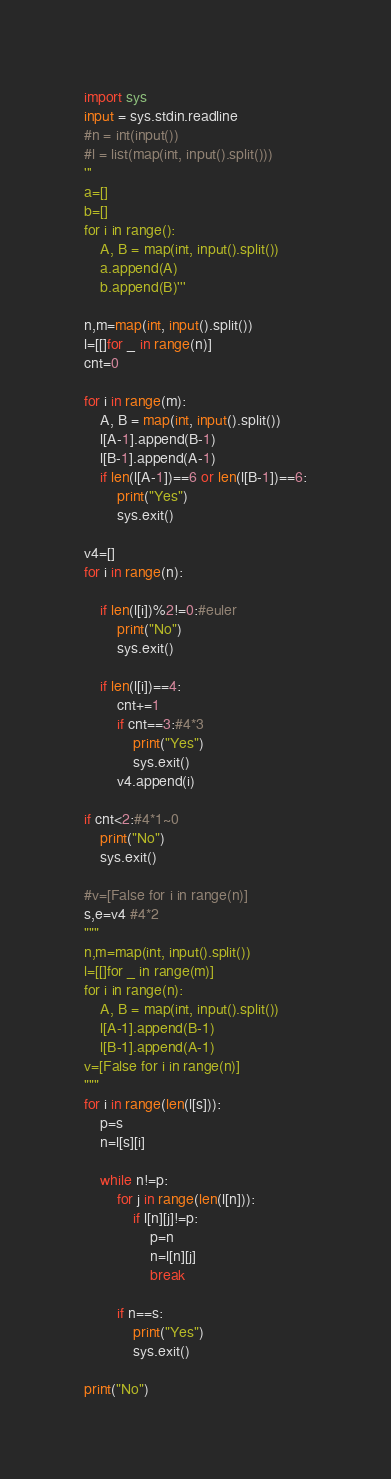Convert code to text. <code><loc_0><loc_0><loc_500><loc_500><_Python_>import sys
input = sys.stdin.readline
#n = int(input())
#l = list(map(int, input().split()))
'''
a=[]
b=[]
for i in range():
    A, B = map(int, input().split())
    a.append(A)
    b.append(B)'''

n,m=map(int, input().split())
l=[[]for _ in range(n)]
cnt=0

for i in range(m):
    A, B = map(int, input().split())
    l[A-1].append(B-1)
    l[B-1].append(A-1)
    if len(l[A-1])==6 or len(l[B-1])==6:
        print("Yes")
        sys.exit()

v4=[]
for i in range(n):

    if len(l[i])%2!=0:#euler
        print("No")
        sys.exit()

    if len(l[i])==4:
        cnt+=1
        if cnt==3:#4*3
            print("Yes")
            sys.exit()
        v4.append(i)

if cnt<2:#4*1~0
    print("No")
    sys.exit()

#v=[False for i in range(n)]
s,e=v4 #4*2
"""
n,m=map(int, input().split())
l=[[]for _ in range(m)]
for i in range(n):
    A, B = map(int, input().split())
    l[A-1].append(B-1)
    l[B-1].append(A-1)
v=[False for i in range(n)]
"""
for i in range(len(l[s])):
    p=s
    n=l[s][i]

    while n!=p:
        for j in range(len(l[n])):
            if l[n][j]!=p:
                p=n
                n=l[n][j]
                break
        
        if n==s:
            print("Yes")
            sys.exit()

print("No")</code> 